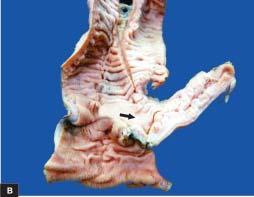what shows an outpouching which on section is seen communicating with the intestinal lumen?
Answer the question using a single word or phrase. Resected segment of the small intestine 